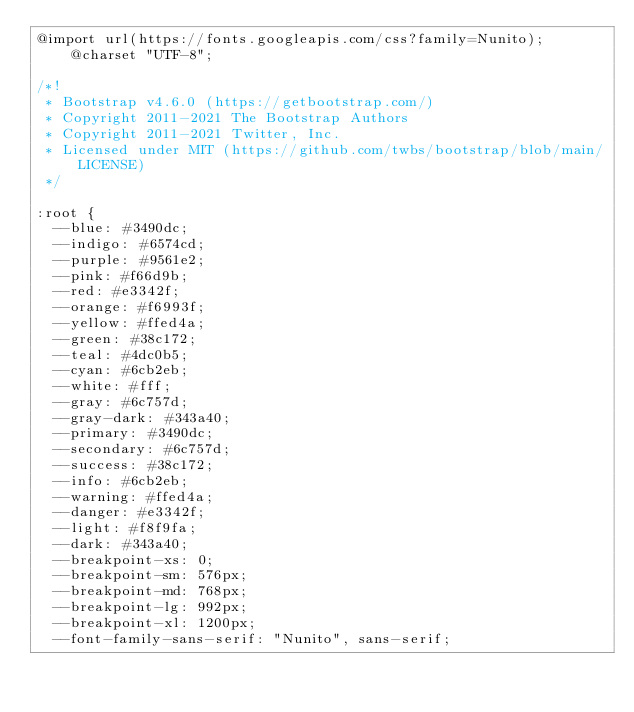Convert code to text. <code><loc_0><loc_0><loc_500><loc_500><_CSS_>@import url(https://fonts.googleapis.com/css?family=Nunito);@charset "UTF-8";

/*!
 * Bootstrap v4.6.0 (https://getbootstrap.com/)
 * Copyright 2011-2021 The Bootstrap Authors
 * Copyright 2011-2021 Twitter, Inc.
 * Licensed under MIT (https://github.com/twbs/bootstrap/blob/main/LICENSE)
 */

:root {
  --blue: #3490dc;
  --indigo: #6574cd;
  --purple: #9561e2;
  --pink: #f66d9b;
  --red: #e3342f;
  --orange: #f6993f;
  --yellow: #ffed4a;
  --green: #38c172;
  --teal: #4dc0b5;
  --cyan: #6cb2eb;
  --white: #fff;
  --gray: #6c757d;
  --gray-dark: #343a40;
  --primary: #3490dc;
  --secondary: #6c757d;
  --success: #38c172;
  --info: #6cb2eb;
  --warning: #ffed4a;
  --danger: #e3342f;
  --light: #f8f9fa;
  --dark: #343a40;
  --breakpoint-xs: 0;
  --breakpoint-sm: 576px;
  --breakpoint-md: 768px;
  --breakpoint-lg: 992px;
  --breakpoint-xl: 1200px;
  --font-family-sans-serif: "Nunito", sans-serif;</code> 